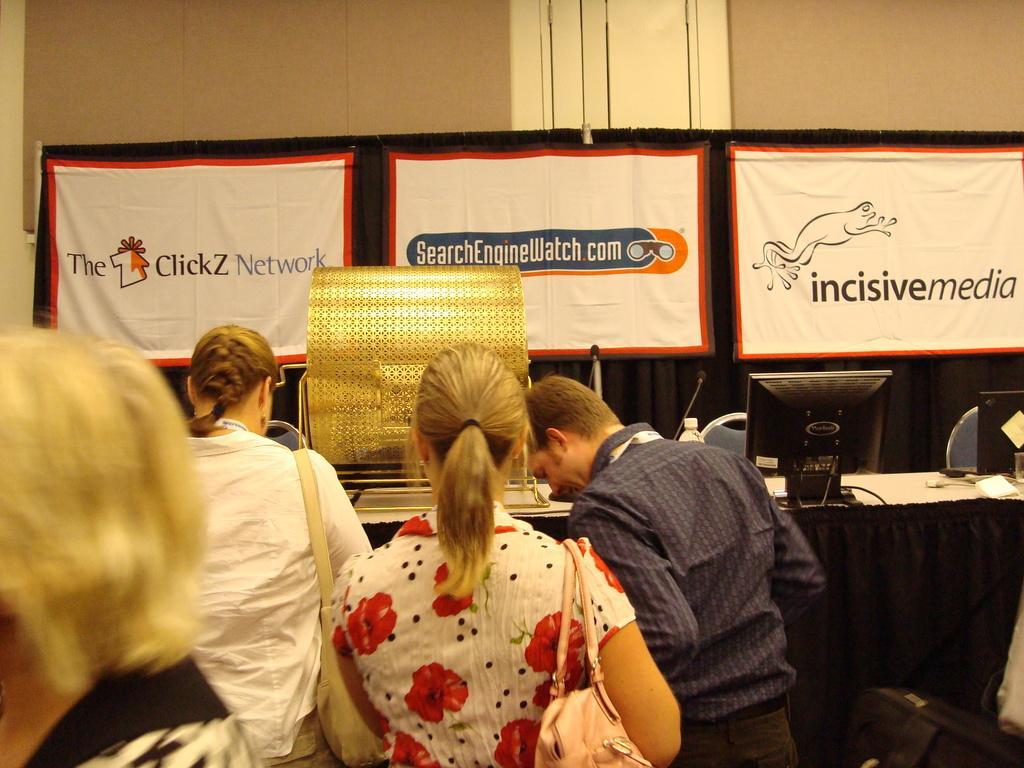Could you give a brief overview of what you see in this image? In this image there are few persons standing in front of the table. On the table there are few monsters, mic's, a bottle and some other objects placed on it, behind the table there is a banner with some text. In the background there is a wall. 